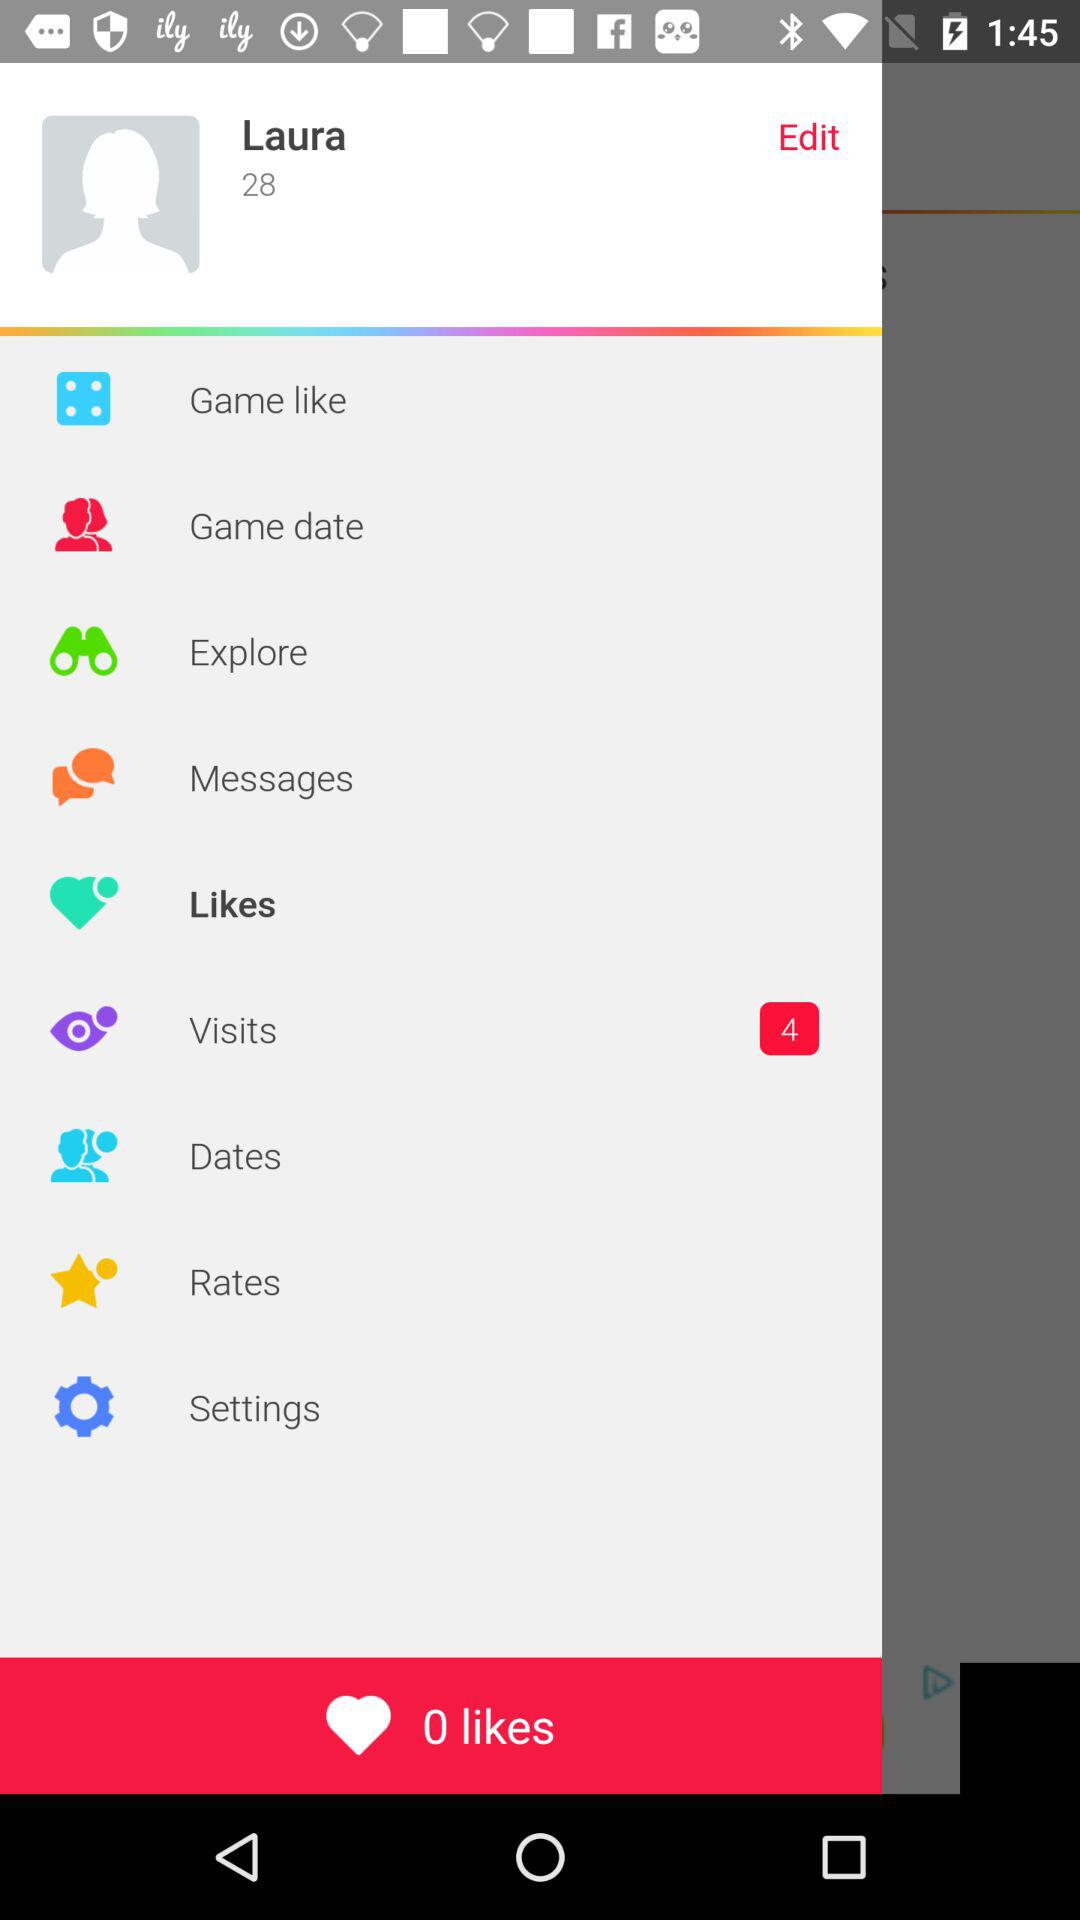What is the number of visits? The number of visits is 4. 